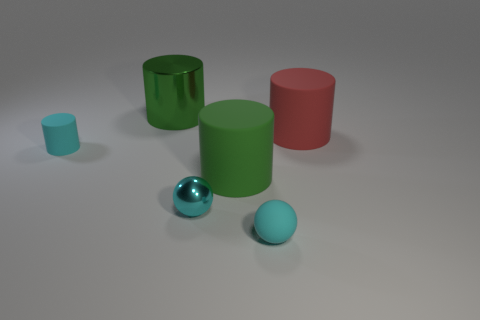What kind of lighting is being used in this scene? The scene appears to be lit with diffused lighting, which creates soft shadows and suggests an indoor environment potentially using studio lighting. 